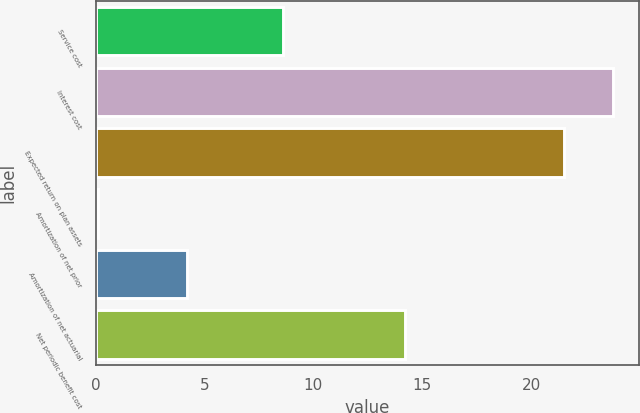Convert chart to OTSL. <chart><loc_0><loc_0><loc_500><loc_500><bar_chart><fcel>Service cost<fcel>Interest cost<fcel>Expected return on plan assets<fcel>Amortization of net prior<fcel>Amortization of net actuarial<fcel>Net periodic benefit cost<nl><fcel>8.6<fcel>23.77<fcel>21.5<fcel>0.1<fcel>4.2<fcel>14.2<nl></chart> 